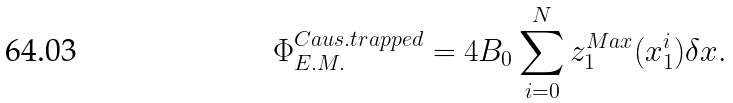<formula> <loc_0><loc_0><loc_500><loc_500>\Phi _ { E . M . } ^ { C a u s . t r a p p e d } = 4 B _ { 0 } \sum _ { i = 0 } ^ { N } z _ { 1 } ^ { M a x } ( x _ { 1 } ^ { i } ) \delta x .</formula> 